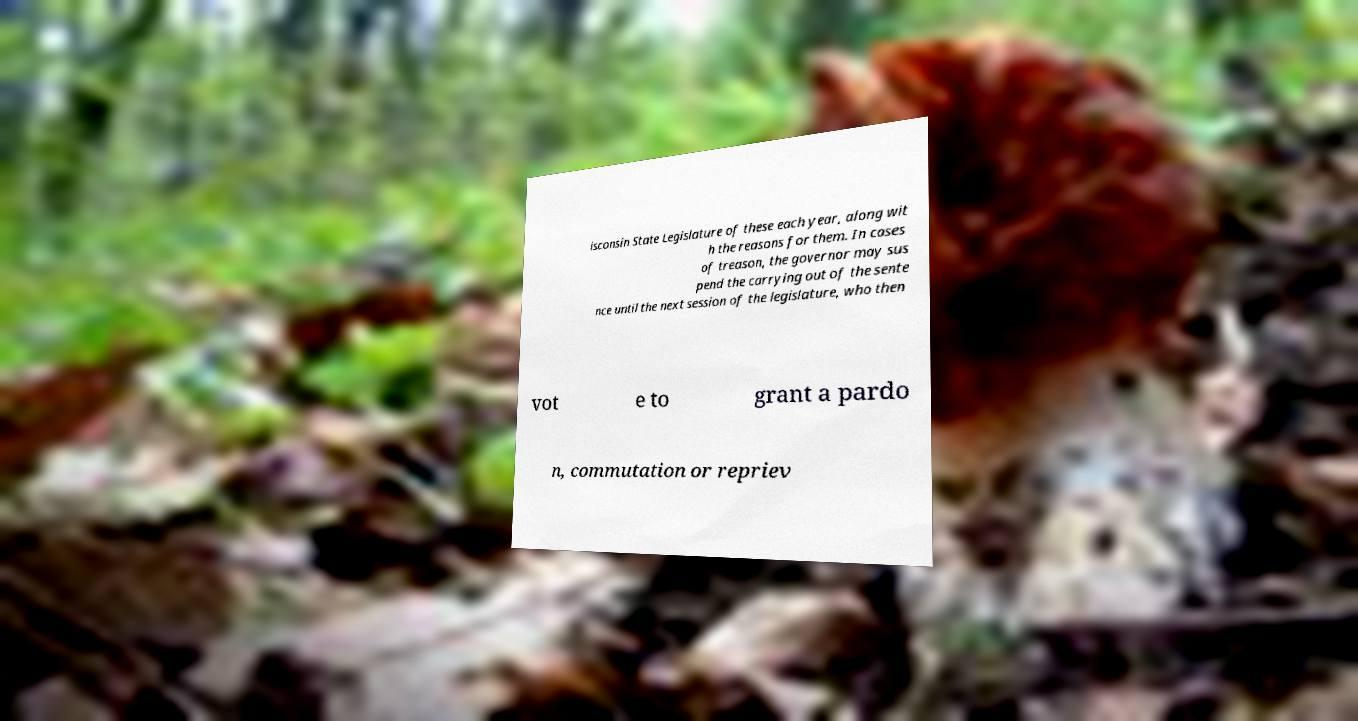Please read and relay the text visible in this image. What does it say? isconsin State Legislature of these each year, along wit h the reasons for them. In cases of treason, the governor may sus pend the carrying out of the sente nce until the next session of the legislature, who then vot e to grant a pardo n, commutation or repriev 